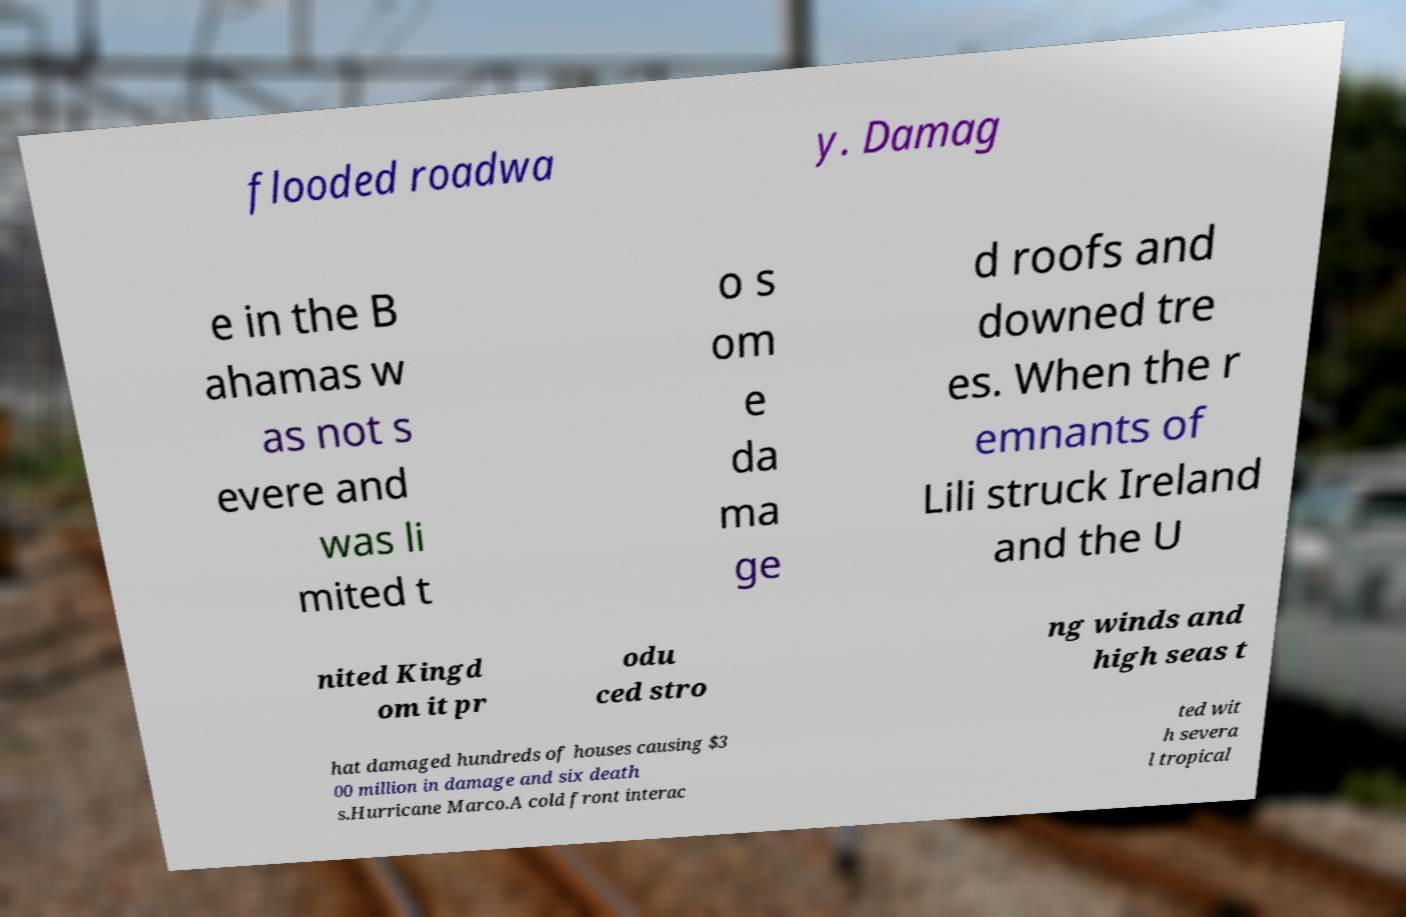I need the written content from this picture converted into text. Can you do that? flooded roadwa y. Damag e in the B ahamas w as not s evere and was li mited t o s om e da ma ge d roofs and downed tre es. When the r emnants of Lili struck Ireland and the U nited Kingd om it pr odu ced stro ng winds and high seas t hat damaged hundreds of houses causing $3 00 million in damage and six death s.Hurricane Marco.A cold front interac ted wit h severa l tropical 